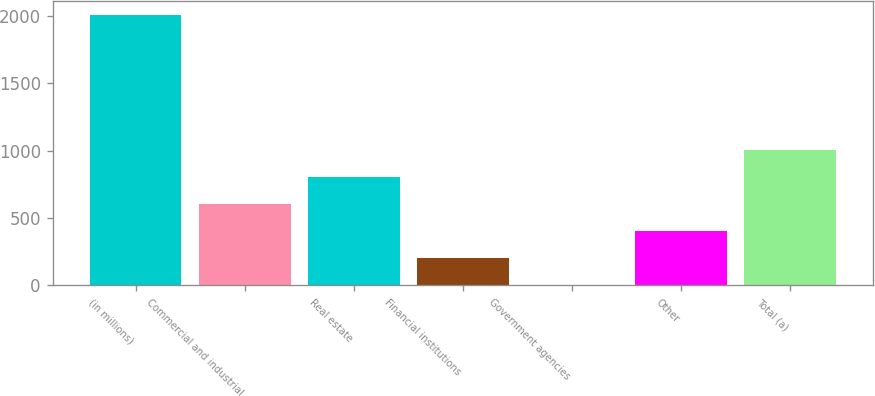<chart> <loc_0><loc_0><loc_500><loc_500><bar_chart><fcel>(in millions)<fcel>Commercial and industrial<fcel>Real estate<fcel>Financial institutions<fcel>Government agencies<fcel>Other<fcel>Total (a)<nl><fcel>2008<fcel>603.1<fcel>803.8<fcel>201.7<fcel>1<fcel>402.4<fcel>1004.5<nl></chart> 